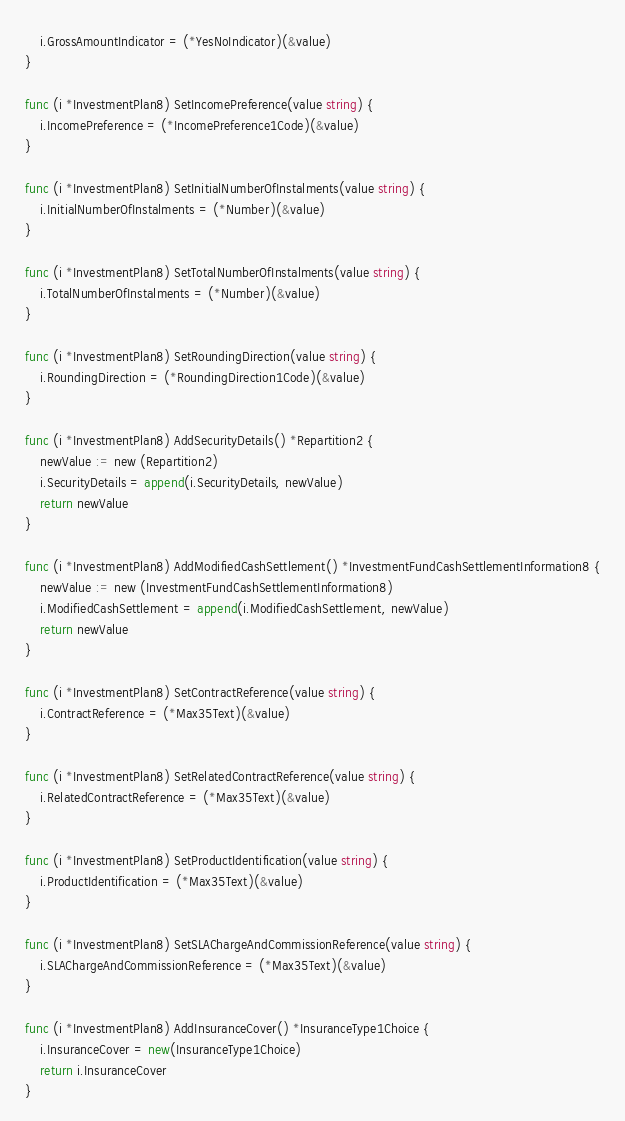Convert code to text. <code><loc_0><loc_0><loc_500><loc_500><_Go_>	i.GrossAmountIndicator = (*YesNoIndicator)(&value)
}

func (i *InvestmentPlan8) SetIncomePreference(value string) {
	i.IncomePreference = (*IncomePreference1Code)(&value)
}

func (i *InvestmentPlan8) SetInitialNumberOfInstalments(value string) {
	i.InitialNumberOfInstalments = (*Number)(&value)
}

func (i *InvestmentPlan8) SetTotalNumberOfInstalments(value string) {
	i.TotalNumberOfInstalments = (*Number)(&value)
}

func (i *InvestmentPlan8) SetRoundingDirection(value string) {
	i.RoundingDirection = (*RoundingDirection1Code)(&value)
}

func (i *InvestmentPlan8) AddSecurityDetails() *Repartition2 {
	newValue := new (Repartition2)
	i.SecurityDetails = append(i.SecurityDetails, newValue)
	return newValue
}

func (i *InvestmentPlan8) AddModifiedCashSettlement() *InvestmentFundCashSettlementInformation8 {
	newValue := new (InvestmentFundCashSettlementInformation8)
	i.ModifiedCashSettlement = append(i.ModifiedCashSettlement, newValue)
	return newValue
}

func (i *InvestmentPlan8) SetContractReference(value string) {
	i.ContractReference = (*Max35Text)(&value)
}

func (i *InvestmentPlan8) SetRelatedContractReference(value string) {
	i.RelatedContractReference = (*Max35Text)(&value)
}

func (i *InvestmentPlan8) SetProductIdentification(value string) {
	i.ProductIdentification = (*Max35Text)(&value)
}

func (i *InvestmentPlan8) SetSLAChargeAndCommissionReference(value string) {
	i.SLAChargeAndCommissionReference = (*Max35Text)(&value)
}

func (i *InvestmentPlan8) AddInsuranceCover() *InsuranceType1Choice {
	i.InsuranceCover = new(InsuranceType1Choice)
	return i.InsuranceCover
}

</code> 